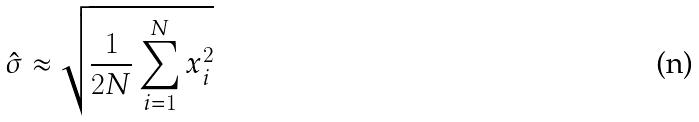<formula> <loc_0><loc_0><loc_500><loc_500>\hat { \sigma } \approx \sqrt { \frac { 1 } { 2 N } \sum _ { i = 1 } ^ { N } x _ { i } ^ { 2 } }</formula> 